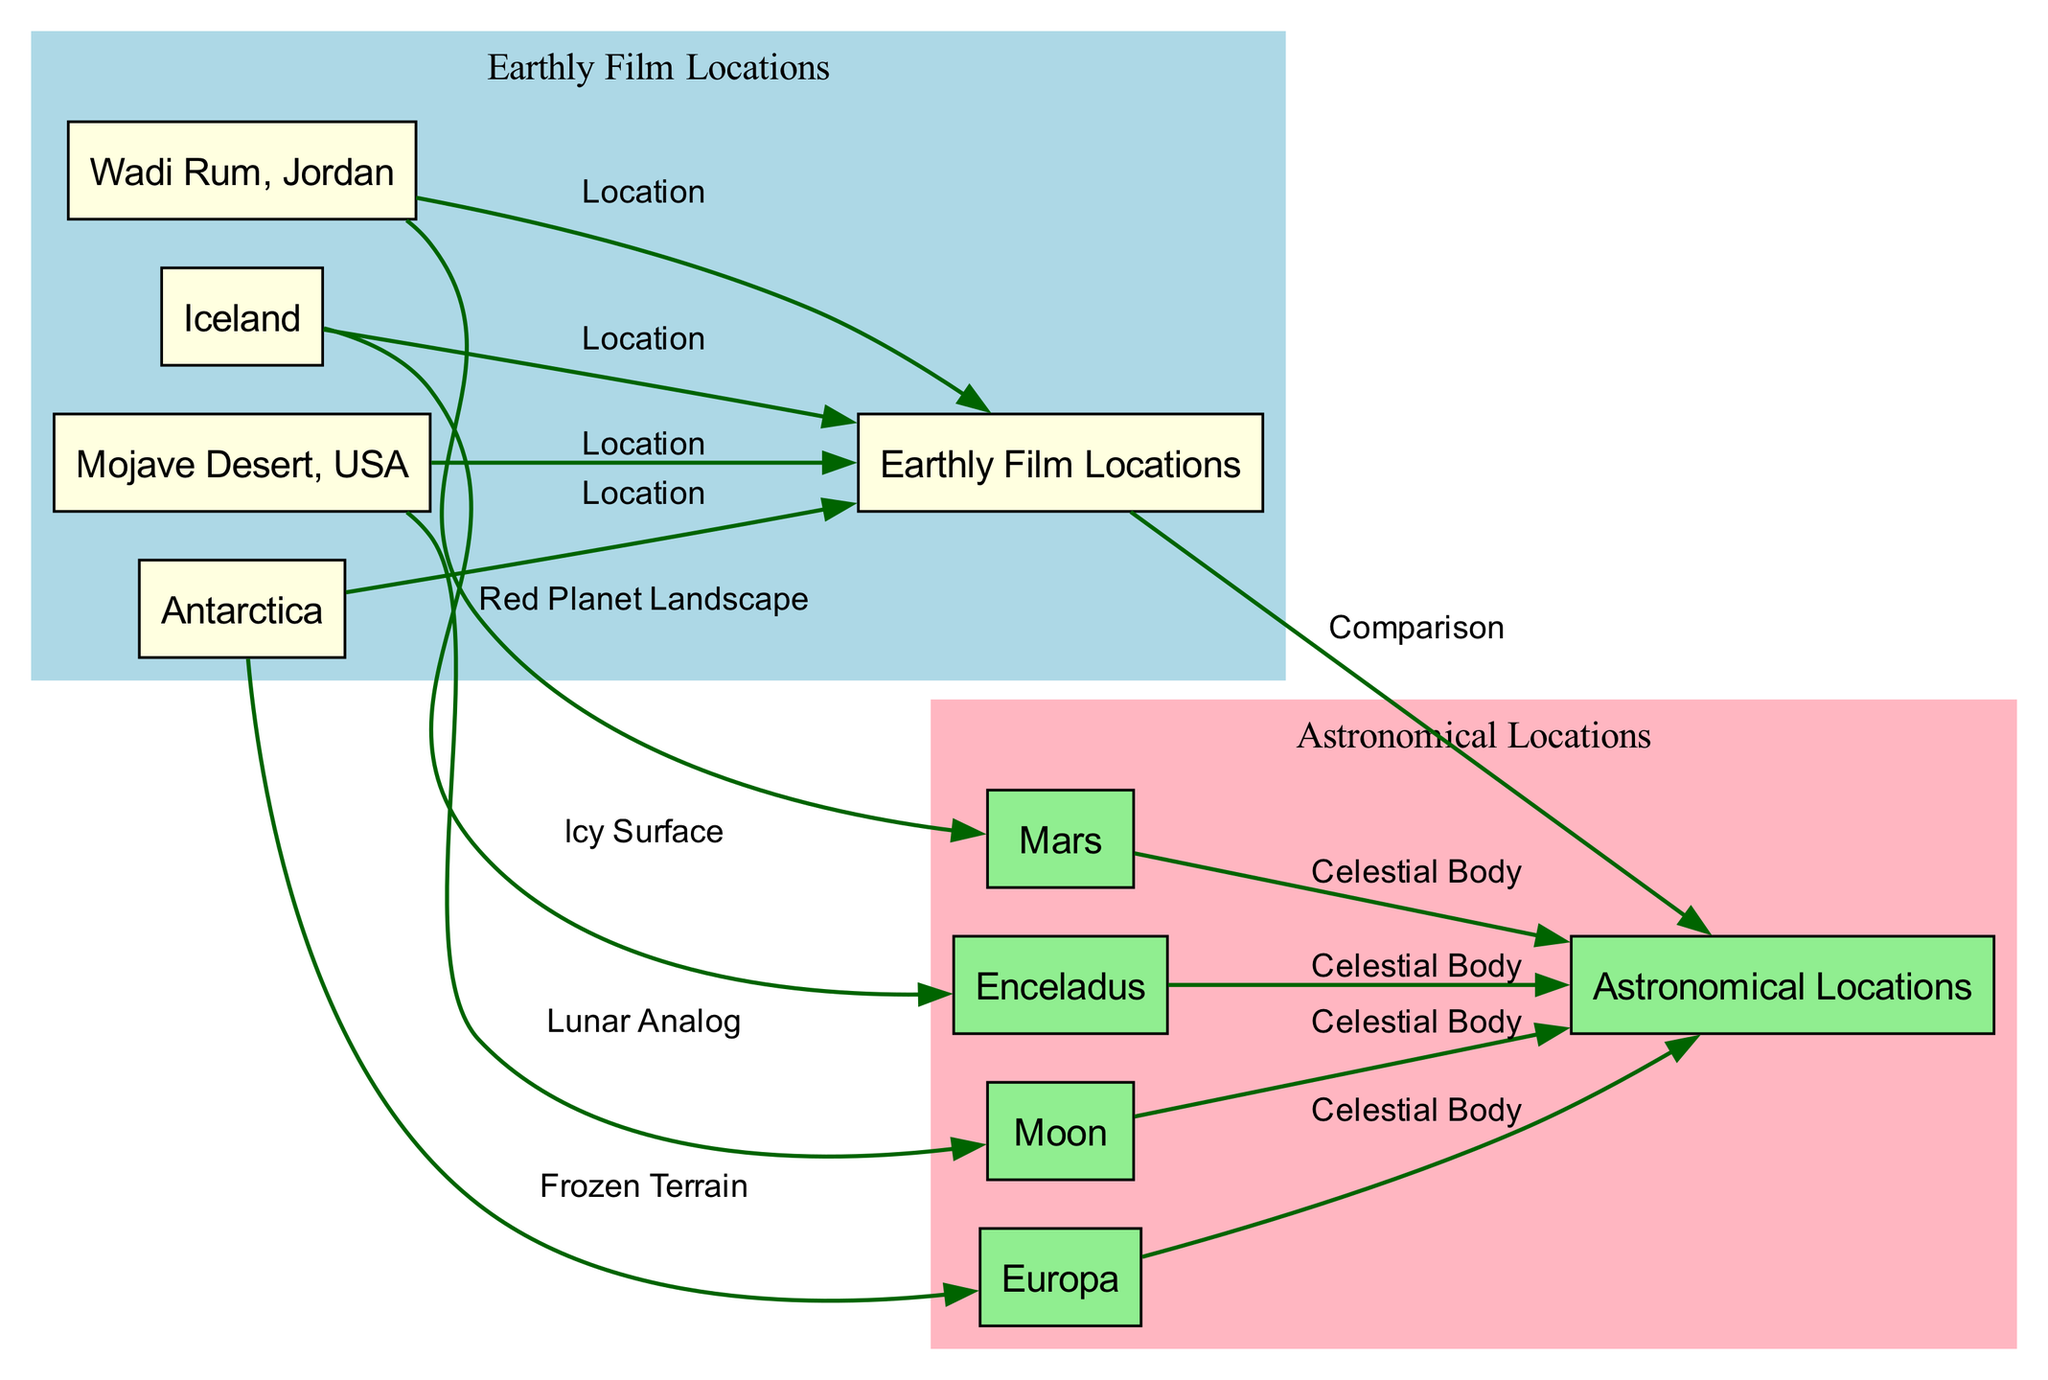What earthly film location is compared to Mars? The diagram shows a directed edge from Wadi Rum, Jordan to Mars indicating that Wadi Rum's landscape is compared to that of Mars, which is specifically labeled as "Red Planet Landscape".
Answer: Wadi Rum, Jordan How many edges connect earthly film locations to astronomical locations? By inspecting the edges in the diagram, there are five edges that connect earthly film locations (like Wadi Rum, Iceland, Mojave Desert, and Antarctica) to their corresponding astronomical locations.
Answer: 5 Which earthly film location corresponds to the Moon? The diagram shows a directed edge from Mojave Desert, USA to the Moon, denoting that the Mojave Desert serves as a lunar analog in film production.
Answer: Mojave Desert, USA How many nodes represent astronomical locations? Observing the diagram, there are five nodes labeled as astronomical locations, which include Mars, Enceladus, Moon, Europa, and their connections.
Answer: 5 What is the relationship between Antarctica and Europa? The diagram illustrates a relationship between Antarctica and Europa, showing that Antarctica's frozen terrain is compared to the icy surfaces found on Europa, indicated by the edge labeled "Frozen Terrain".
Answer: Frozen Terrain What feature distinguishes Iceland in its comparison? The edge connecting Iceland and Enceladus is labeled "Icy Surface," indicating that the distinguishing feature for Iceland in this comparison is its icy characteristics.
Answer: Icy Surface Which Earthly Film Location is linked to both Mars and the Moon? According to the diagram, the Mojave Desert, USA has outgoing edges to both the Moon and Mars, establishing connections to these two celestial bodies through its landscape representation.
Answer: Mojave Desert, USA What color represents the Astronomical Locations in the diagram? In the diagram, the astronomical locations are represented with light pink coloring in the nodes, distinguishing them from earthly locations, which are light yellow.
Answer: Light pink 